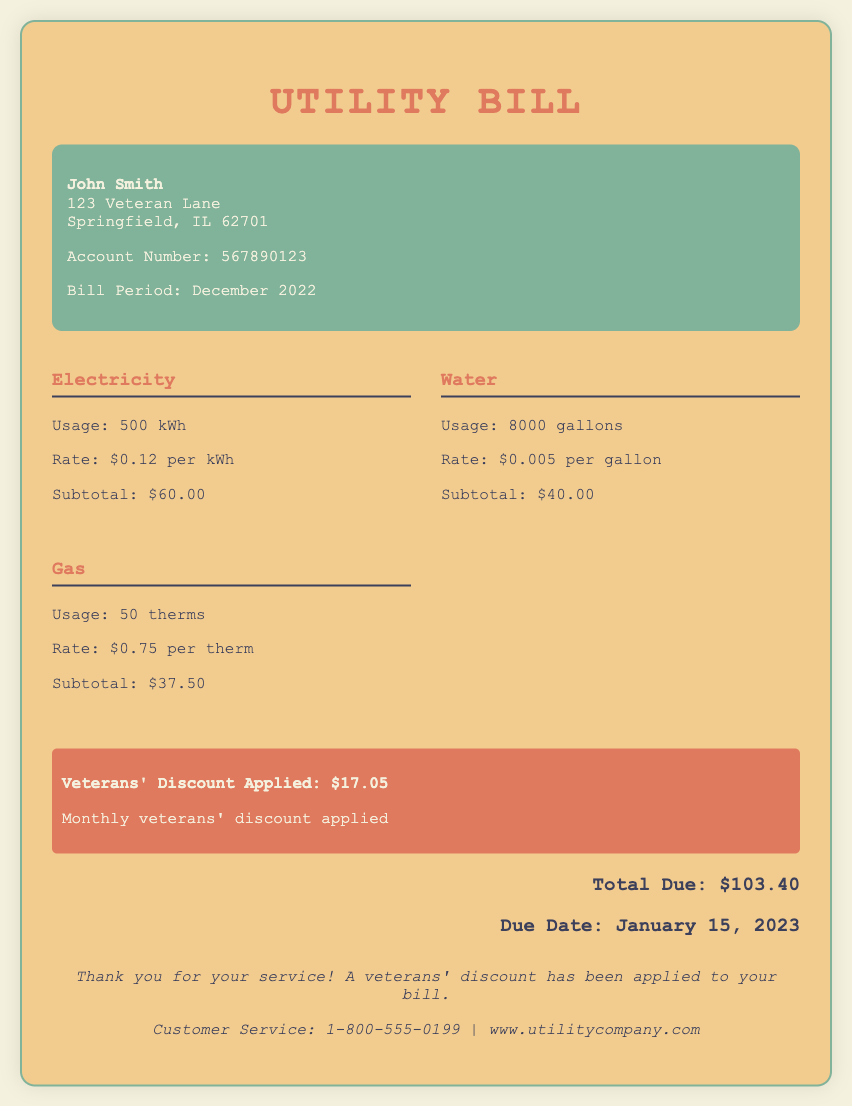what is the usage for electricity? The usage for electricity is stated in the document as 500 kWh.
Answer: 500 kWh what is the subtotal for water? The subtotal for water is clearly indicated in the water section of the document, which is $40.00.
Answer: $40.00 who is the account holder? The account holder is named at the top of the document as John Smith.
Answer: John Smith when is the due date for the bill? The due date for the bill is specified in the total section as January 15, 2023.
Answer: January 15, 2023 what is the total amount due? The total due amount is presented at the bottom of the document, which is $103.40.
Answer: $103.40 what type of discount is applied to the bill? The document mentions that a veterans' discount has been applied to the bill.
Answer: Veterans' Discount how much is the veterans' discount? The document explicitly states the amount of the veterans' discount as $17.05.
Answer: $17.05 how many gallons of water were used? The usage for water is mentioned in the document as 8000 gallons.
Answer: 8000 gallons what is the rate per therm for gas? The rate per therm for gas is provided as $0.75 per therm in the gas section.
Answer: $0.75 per therm 